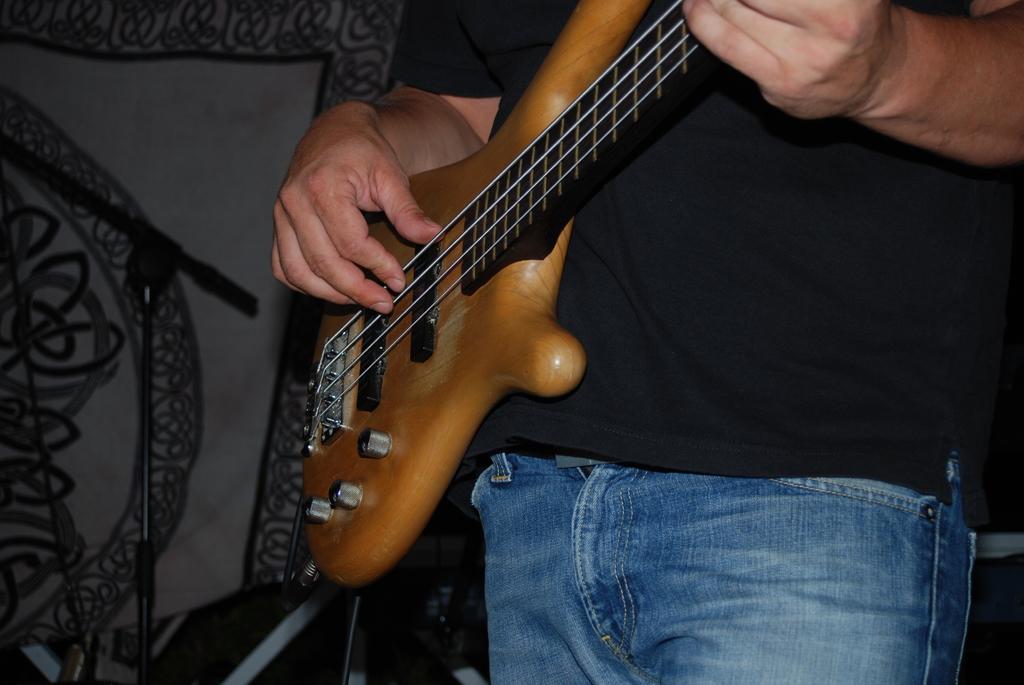Please provide a concise description of this image. Person is playing guitar. 